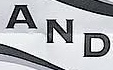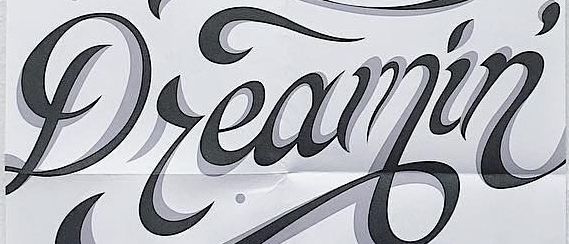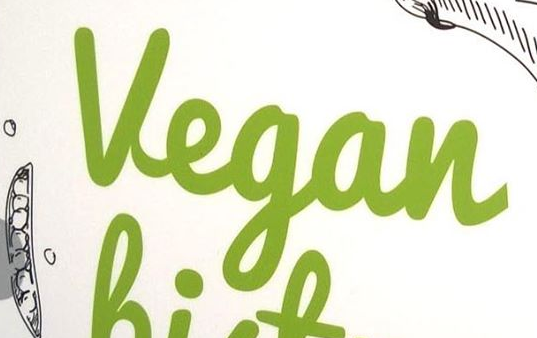Transcribe the words shown in these images in order, separated by a semicolon. AND; Dreamin'; Vegan 